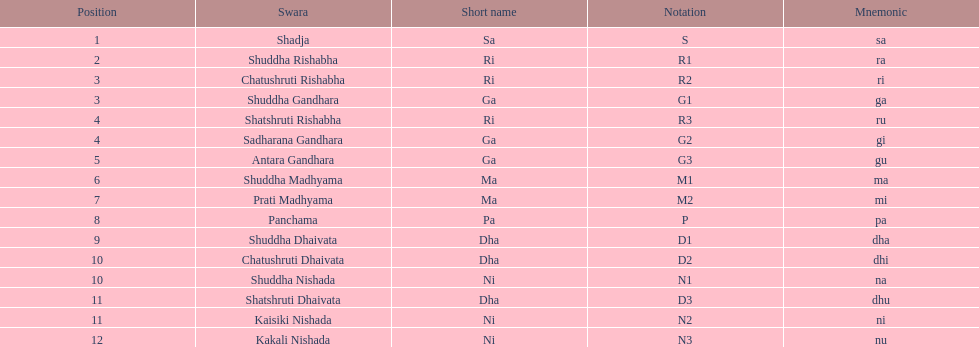Which swara follows immediately after antara gandhara? Shuddha Madhyama. 